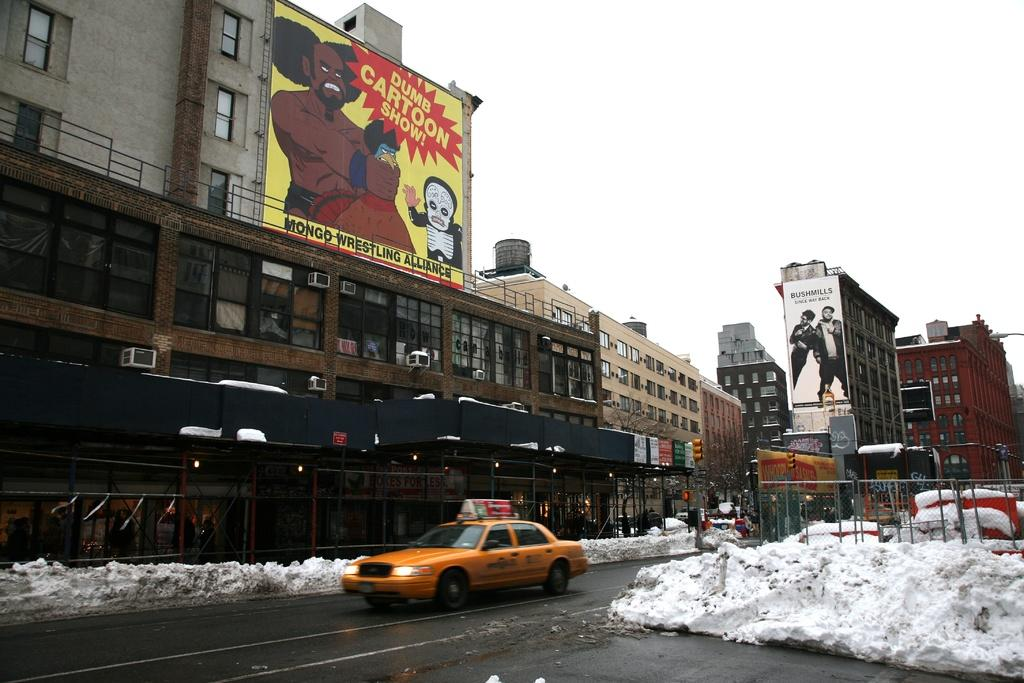<image>
Create a compact narrative representing the image presented. A mural on a building shows a dumb Cartoon show. 